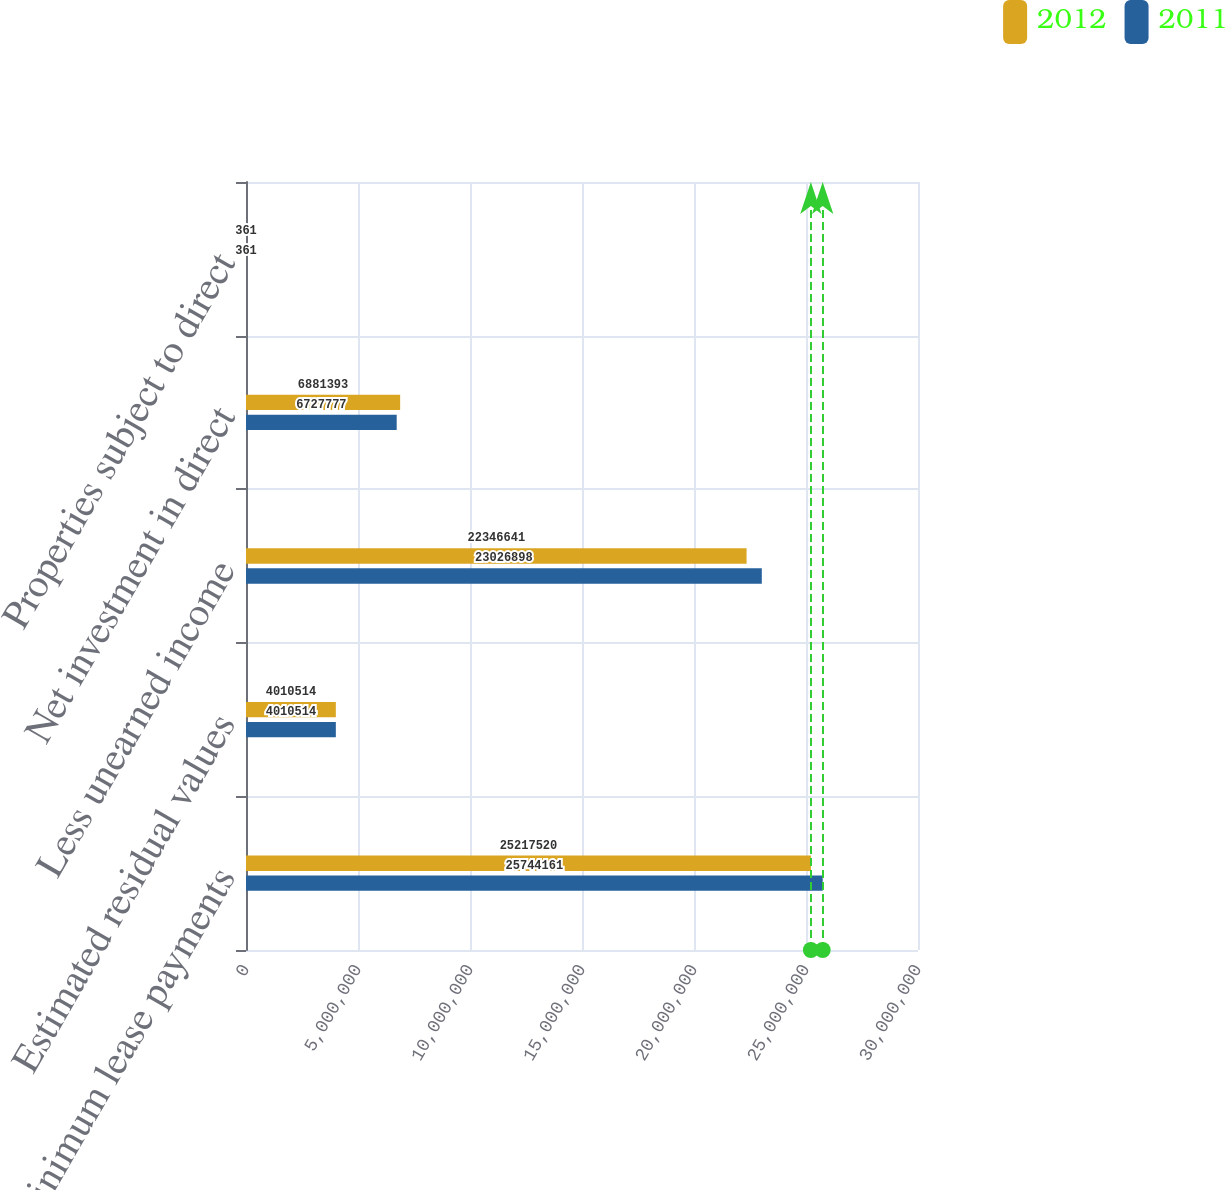Convert chart to OTSL. <chart><loc_0><loc_0><loc_500><loc_500><stacked_bar_chart><ecel><fcel>Minimum lease payments<fcel>Estimated residual values<fcel>Less unearned income<fcel>Net investment in direct<fcel>Properties subject to direct<nl><fcel>2012<fcel>2.52175e+07<fcel>4.01051e+06<fcel>2.23466e+07<fcel>6.88139e+06<fcel>361<nl><fcel>2011<fcel>2.57442e+07<fcel>4.01051e+06<fcel>2.30269e+07<fcel>6.72778e+06<fcel>361<nl></chart> 